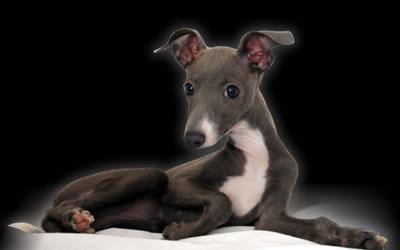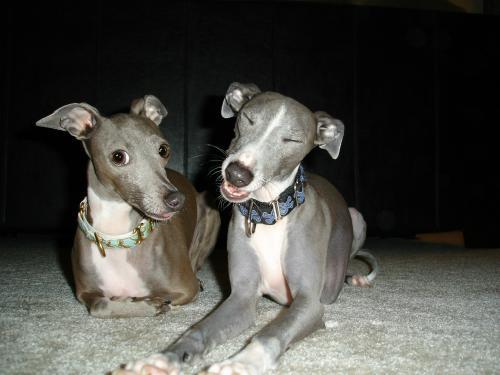The first image is the image on the left, the second image is the image on the right. Examine the images to the left and right. Is the description "At least one dog in the image on the right is wearing a collar." accurate? Answer yes or no. Yes. The first image is the image on the left, the second image is the image on the right. Given the left and right images, does the statement "The right image contains at least one dog wearing a collar." hold true? Answer yes or no. Yes. 